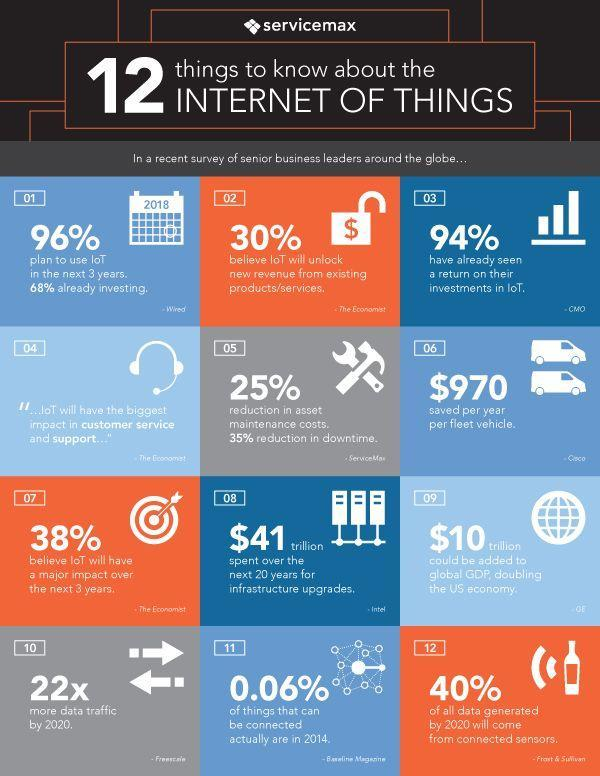How much can be spent in infrastructure upgrades in the next 20 years?
Answer the question with a short phrase. $41 Trillion How much can be added to double the US economy? $10 trillion What percentage of senior business leaders have had a return on their investments in IoT? 94% What percentage plan to use IoT in the next 3 years? 96% 